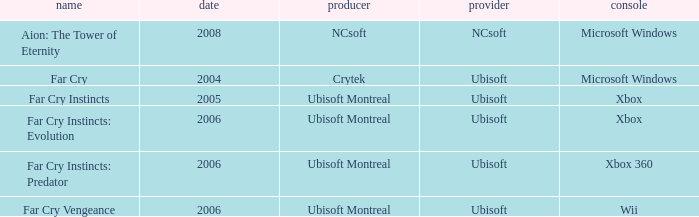Which publisher has Far Cry as the title? Ubisoft. 